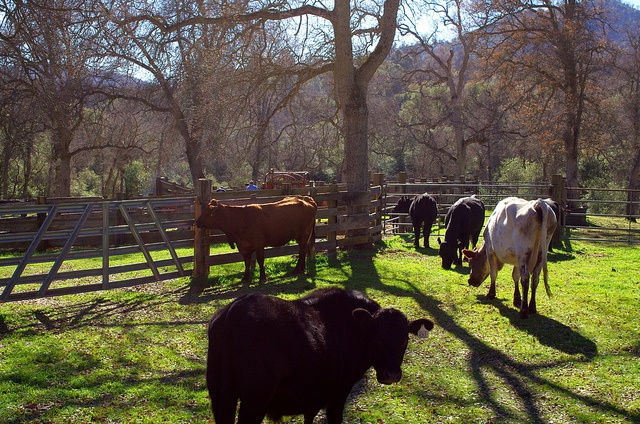Describe the objects in this image and their specific colors. I can see cow in lightblue, black, gray, and olive tones, cow in lightblue, gray, black, maroon, and olive tones, cow in lightblue, black, maroon, and tan tones, cow in lightblue, black, gray, darkgray, and olive tones, and cow in lightblue, black, gray, and darkgray tones in this image. 